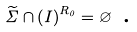Convert formula to latex. <formula><loc_0><loc_0><loc_500><loc_500>\widetilde { \Sigma } \cap \left ( I \right ) ^ { R _ { 0 } } = \varnothing \text { .}</formula> 